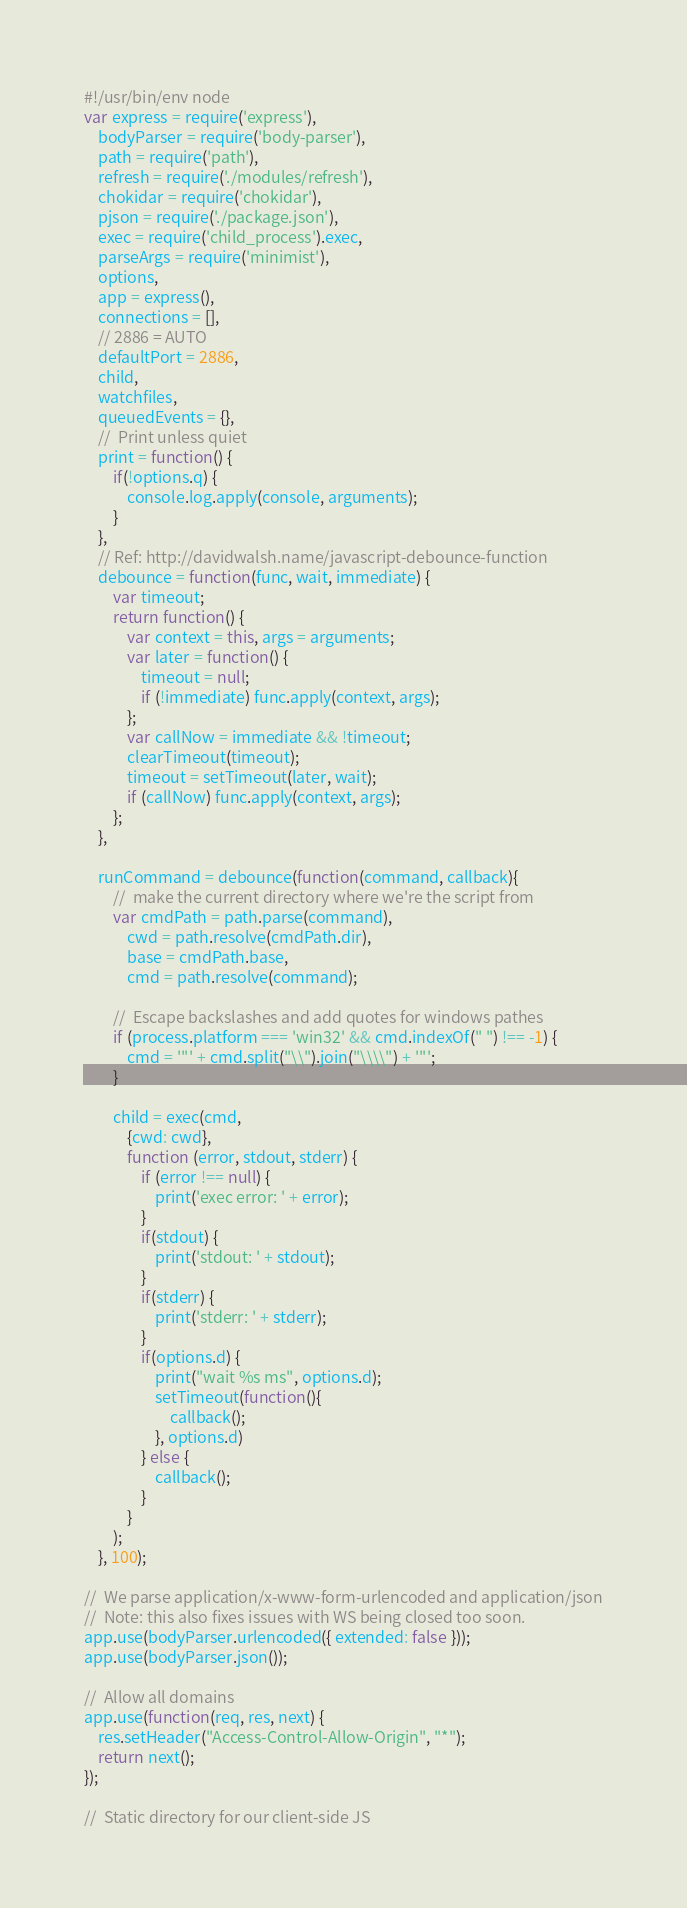<code> <loc_0><loc_0><loc_500><loc_500><_JavaScript_>#!/usr/bin/env node
var express = require('express'),
	bodyParser = require('body-parser'),
	path = require('path'),
	refresh = require('./modules/refresh'),
	chokidar = require('chokidar'),
	pjson = require('./package.json'),
	exec = require('child_process').exec,
	parseArgs = require('minimist'),
	options,
	app = express(),
	connections = [],
	// 2886 = AUTO
	defaultPort = 2886,
	child,
	watchfiles,
	queuedEvents = {},
	//	Print unless quiet
	print = function() {
		if(!options.q) {
			console.log.apply(console, arguments);
		}
	},
	// Ref: http://davidwalsh.name/javascript-debounce-function
	debounce = function(func, wait, immediate) {
		var timeout;
		return function() {
			var context = this, args = arguments;
			var later = function() {
				timeout = null;
				if (!immediate) func.apply(context, args);
			};
			var callNow = immediate && !timeout;
			clearTimeout(timeout);
			timeout = setTimeout(later, wait);
			if (callNow) func.apply(context, args);
		};
	},

	runCommand = debounce(function(command, callback){
		//	make the current directory where we're the script from
		var cmdPath = path.parse(command),
			cwd = path.resolve(cmdPath.dir),
			base = cmdPath.base,
			cmd = path.resolve(command);

		//	Escape backslashes and add quotes for windows pathes
		if (process.platform === 'win32' && cmd.indexOf(" ") !== -1) {
			cmd = '"' + cmd.split("\\").join("\\\\") + '"';
		}

		child = exec(cmd,
			{cwd: cwd},
			function (error, stdout, stderr) {
				if (error !== null) {
					print('exec error: ' + error);
				}
				if(stdout) {
					print('stdout: ' + stdout);
				}
				if(stderr) {
					print('stderr: ' + stderr);
				}
				if(options.d) {
					print("wait %s ms", options.d);
					setTimeout(function(){
						callback();
					}, options.d)
				} else {
					callback();
				}
			}
		);
	}, 100);

//	We parse application/x-www-form-urlencoded and application/json
//	Note: this also fixes issues with WS being closed too soon.
app.use(bodyParser.urlencoded({ extended: false }));
app.use(bodyParser.json());

//	Allow all domains
app.use(function(req, res, next) {
	res.setHeader("Access-Control-Allow-Origin", "*");
	return next();
});

//	Static directory for our client-side JS</code> 